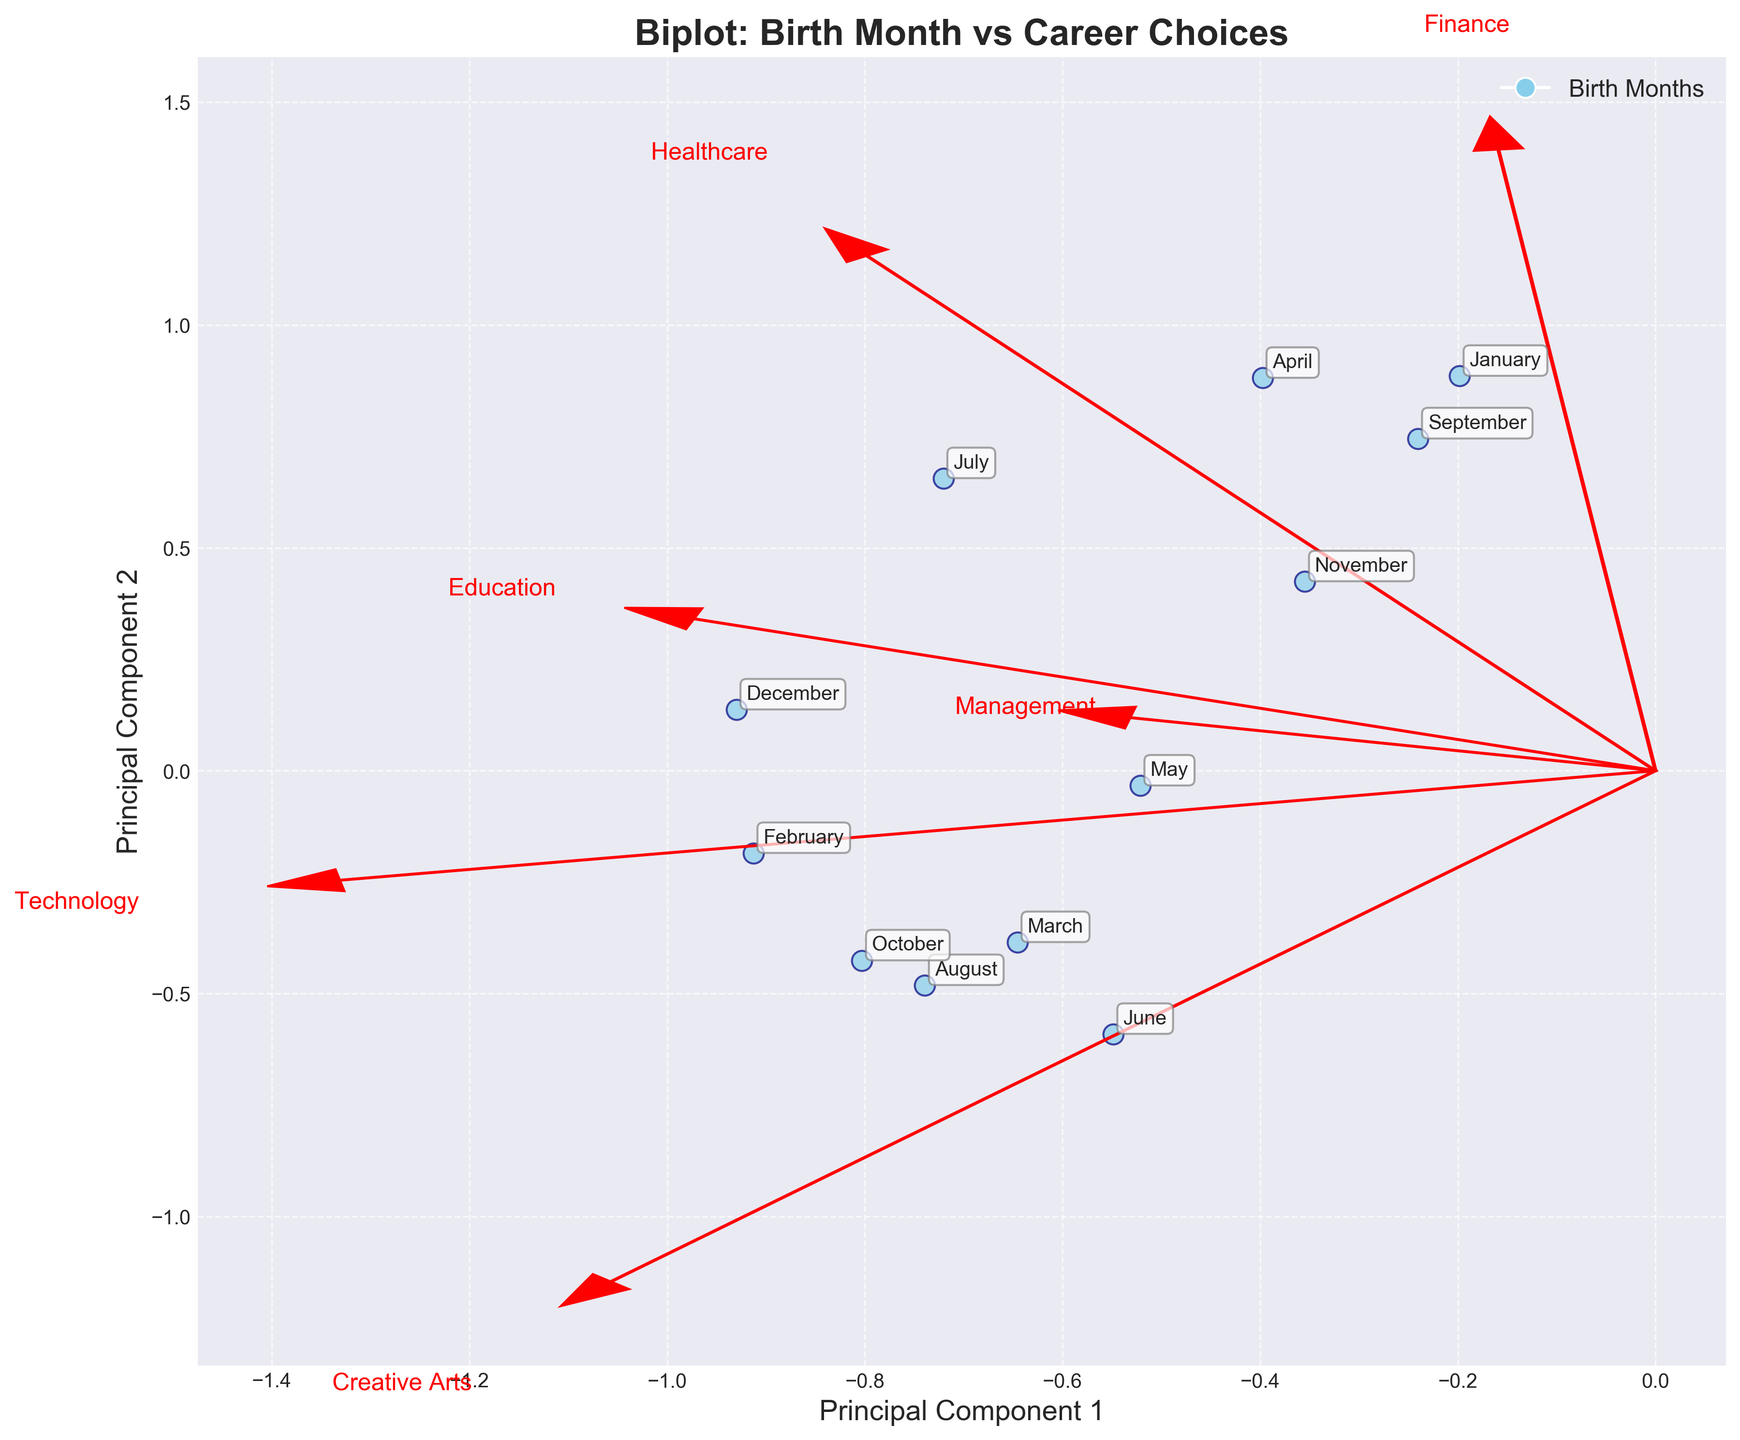What is the title of the figure? The title is written at the top of the chart. In this case, it clearly states, "Biplot: Birth Month vs Career Choices."
Answer: Biplot: Birth Month vs Career Choices How many birth months are represented in the plot? Each data point on the plot represents one birth month. By counting the annotations, you can see there are 12 different birth months labeled on the figure.
Answer: 12 Which birth month is closest to the origin? To find which birth month is closest to the origin (0,0), look for the data point that is nearest to the center of the plot. March appears to be the closest.
Answer: March Which industry corresponds to the vector pointing most vertically upward? The vector that points most vertically upward has the highest value along the PC2 axis. From the plot, the Healthcare vector points most upward.
Answer: Healthcare Which birth month lies furthest to the right on the PC1 axis? To determine this, locate the data point with the highest PC1 value. January appears furthest to the right on the PC1 axis.
Answer: January Which industry vector is closest to the January birth month data point? Look at the position of the industry vectors and observe which one is closest to the January data point. The Finance vector appears to be the closest.
Answer: Finance Is the birth month July associated more with Technology or Finance? Check which vector (Technology or Finance) is closer to the July data point on the plot. July is closer to the Technology vector.
Answer: Technology Which birth months are associated with high values in Education? Examine the direction of the Education vector and identify the birth months that lie close to this direction. April and November are closely aligned with Education.
Answer: April and November What are the two principal components displayed on the axes? Look at the axis labels: the x-axis is labeled "Principal Component 1" and the y-axis is labeled "Principal Component 2." These two principal components are the axes in the biplot.
Answer: Principal Component 1 and Principal Component 2 Which birth month is closest to the Creative Arts vector? Identify the birth month data point that is nearest to the Creative Arts vector. March lies closest to the Creative Arts vector.
Answer: March 